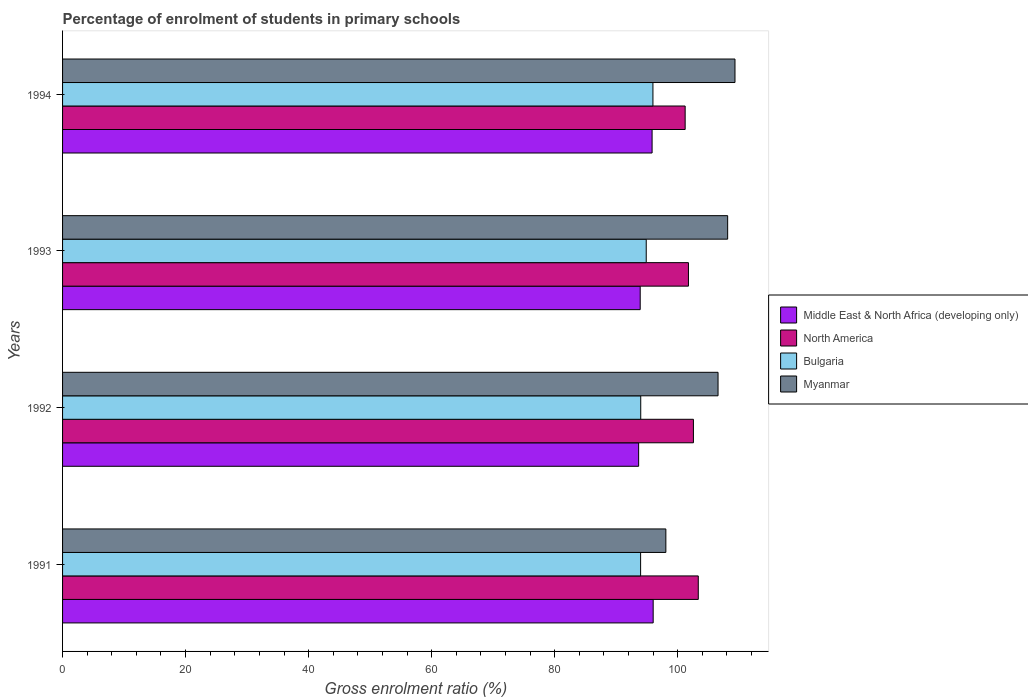How many groups of bars are there?
Your answer should be very brief. 4. Are the number of bars per tick equal to the number of legend labels?
Provide a succinct answer. Yes. How many bars are there on the 3rd tick from the top?
Make the answer very short. 4. How many bars are there on the 1st tick from the bottom?
Your answer should be very brief. 4. What is the label of the 3rd group of bars from the top?
Give a very brief answer. 1992. What is the percentage of students enrolled in primary schools in Bulgaria in 1994?
Offer a very short reply. 95.97. Across all years, what is the maximum percentage of students enrolled in primary schools in North America?
Ensure brevity in your answer.  103.35. Across all years, what is the minimum percentage of students enrolled in primary schools in Myanmar?
Provide a short and direct response. 98.07. What is the total percentage of students enrolled in primary schools in Bulgaria in the graph?
Give a very brief answer. 378.81. What is the difference between the percentage of students enrolled in primary schools in Bulgaria in 1991 and that in 1993?
Your response must be concise. -0.91. What is the difference between the percentage of students enrolled in primary schools in North America in 1993 and the percentage of students enrolled in primary schools in Middle East & North Africa (developing only) in 1991?
Make the answer very short. 5.73. What is the average percentage of students enrolled in primary schools in Bulgaria per year?
Make the answer very short. 94.7. In the year 1992, what is the difference between the percentage of students enrolled in primary schools in North America and percentage of students enrolled in primary schools in Myanmar?
Offer a terse response. -4. In how many years, is the percentage of students enrolled in primary schools in Bulgaria greater than 76 %?
Ensure brevity in your answer.  4. What is the ratio of the percentage of students enrolled in primary schools in Myanmar in 1993 to that in 1994?
Provide a succinct answer. 0.99. What is the difference between the highest and the second highest percentage of students enrolled in primary schools in Myanmar?
Offer a terse response. 1.19. What is the difference between the highest and the lowest percentage of students enrolled in primary schools in Bulgaria?
Provide a short and direct response. 2.01. Is the sum of the percentage of students enrolled in primary schools in North America in 1993 and 1994 greater than the maximum percentage of students enrolled in primary schools in Middle East & North Africa (developing only) across all years?
Provide a succinct answer. Yes. What does the 3rd bar from the bottom in 1994 represents?
Your answer should be compact. Bulgaria. Is it the case that in every year, the sum of the percentage of students enrolled in primary schools in Myanmar and percentage of students enrolled in primary schools in Bulgaria is greater than the percentage of students enrolled in primary schools in Middle East & North Africa (developing only)?
Your answer should be compact. Yes. Are all the bars in the graph horizontal?
Offer a terse response. Yes. How many years are there in the graph?
Offer a terse response. 4. What is the difference between two consecutive major ticks on the X-axis?
Give a very brief answer. 20. Does the graph contain any zero values?
Ensure brevity in your answer.  No. Does the graph contain grids?
Make the answer very short. No. What is the title of the graph?
Keep it short and to the point. Percentage of enrolment of students in primary schools. What is the Gross enrolment ratio (%) in Middle East & North Africa (developing only) in 1991?
Make the answer very short. 96.01. What is the Gross enrolment ratio (%) in North America in 1991?
Provide a succinct answer. 103.35. What is the Gross enrolment ratio (%) of Bulgaria in 1991?
Offer a terse response. 93.97. What is the Gross enrolment ratio (%) of Myanmar in 1991?
Your answer should be very brief. 98.07. What is the Gross enrolment ratio (%) in Middle East & North Africa (developing only) in 1992?
Provide a short and direct response. 93.65. What is the Gross enrolment ratio (%) of North America in 1992?
Offer a very short reply. 102.56. What is the Gross enrolment ratio (%) in Bulgaria in 1992?
Your response must be concise. 93.99. What is the Gross enrolment ratio (%) of Myanmar in 1992?
Your answer should be compact. 106.56. What is the Gross enrolment ratio (%) of Middle East & North Africa (developing only) in 1993?
Give a very brief answer. 93.9. What is the Gross enrolment ratio (%) in North America in 1993?
Make the answer very short. 101.75. What is the Gross enrolment ratio (%) of Bulgaria in 1993?
Provide a short and direct response. 94.88. What is the Gross enrolment ratio (%) in Myanmar in 1993?
Keep it short and to the point. 108.12. What is the Gross enrolment ratio (%) in Middle East & North Africa (developing only) in 1994?
Keep it short and to the point. 95.84. What is the Gross enrolment ratio (%) in North America in 1994?
Offer a very short reply. 101.21. What is the Gross enrolment ratio (%) in Bulgaria in 1994?
Provide a succinct answer. 95.97. What is the Gross enrolment ratio (%) of Myanmar in 1994?
Offer a terse response. 109.31. Across all years, what is the maximum Gross enrolment ratio (%) in Middle East & North Africa (developing only)?
Offer a terse response. 96.01. Across all years, what is the maximum Gross enrolment ratio (%) of North America?
Provide a succinct answer. 103.35. Across all years, what is the maximum Gross enrolment ratio (%) in Bulgaria?
Provide a succinct answer. 95.97. Across all years, what is the maximum Gross enrolment ratio (%) of Myanmar?
Your answer should be compact. 109.31. Across all years, what is the minimum Gross enrolment ratio (%) in Middle East & North Africa (developing only)?
Offer a terse response. 93.65. Across all years, what is the minimum Gross enrolment ratio (%) of North America?
Your answer should be very brief. 101.21. Across all years, what is the minimum Gross enrolment ratio (%) of Bulgaria?
Make the answer very short. 93.97. Across all years, what is the minimum Gross enrolment ratio (%) in Myanmar?
Provide a succinct answer. 98.07. What is the total Gross enrolment ratio (%) in Middle East & North Africa (developing only) in the graph?
Make the answer very short. 379.4. What is the total Gross enrolment ratio (%) in North America in the graph?
Offer a very short reply. 408.86. What is the total Gross enrolment ratio (%) in Bulgaria in the graph?
Give a very brief answer. 378.81. What is the total Gross enrolment ratio (%) of Myanmar in the graph?
Provide a short and direct response. 422.06. What is the difference between the Gross enrolment ratio (%) in Middle East & North Africa (developing only) in 1991 and that in 1992?
Offer a very short reply. 2.36. What is the difference between the Gross enrolment ratio (%) of North America in 1991 and that in 1992?
Offer a terse response. 0.79. What is the difference between the Gross enrolment ratio (%) in Bulgaria in 1991 and that in 1992?
Ensure brevity in your answer.  -0.02. What is the difference between the Gross enrolment ratio (%) of Myanmar in 1991 and that in 1992?
Provide a succinct answer. -8.48. What is the difference between the Gross enrolment ratio (%) of Middle East & North Africa (developing only) in 1991 and that in 1993?
Provide a succinct answer. 2.11. What is the difference between the Gross enrolment ratio (%) in North America in 1991 and that in 1993?
Give a very brief answer. 1.6. What is the difference between the Gross enrolment ratio (%) of Bulgaria in 1991 and that in 1993?
Your answer should be very brief. -0.91. What is the difference between the Gross enrolment ratio (%) of Myanmar in 1991 and that in 1993?
Offer a terse response. -10.05. What is the difference between the Gross enrolment ratio (%) of Middle East & North Africa (developing only) in 1991 and that in 1994?
Give a very brief answer. 0.18. What is the difference between the Gross enrolment ratio (%) in North America in 1991 and that in 1994?
Provide a succinct answer. 2.13. What is the difference between the Gross enrolment ratio (%) of Bulgaria in 1991 and that in 1994?
Keep it short and to the point. -2.01. What is the difference between the Gross enrolment ratio (%) of Myanmar in 1991 and that in 1994?
Your response must be concise. -11.24. What is the difference between the Gross enrolment ratio (%) of Middle East & North Africa (developing only) in 1992 and that in 1993?
Provide a succinct answer. -0.25. What is the difference between the Gross enrolment ratio (%) of North America in 1992 and that in 1993?
Provide a short and direct response. 0.81. What is the difference between the Gross enrolment ratio (%) of Bulgaria in 1992 and that in 1993?
Keep it short and to the point. -0.89. What is the difference between the Gross enrolment ratio (%) of Myanmar in 1992 and that in 1993?
Your answer should be very brief. -1.56. What is the difference between the Gross enrolment ratio (%) of Middle East & North Africa (developing only) in 1992 and that in 1994?
Ensure brevity in your answer.  -2.19. What is the difference between the Gross enrolment ratio (%) in North America in 1992 and that in 1994?
Your response must be concise. 1.34. What is the difference between the Gross enrolment ratio (%) of Bulgaria in 1992 and that in 1994?
Your response must be concise. -1.98. What is the difference between the Gross enrolment ratio (%) in Myanmar in 1992 and that in 1994?
Your response must be concise. -2.75. What is the difference between the Gross enrolment ratio (%) of Middle East & North Africa (developing only) in 1993 and that in 1994?
Ensure brevity in your answer.  -1.93. What is the difference between the Gross enrolment ratio (%) of North America in 1993 and that in 1994?
Provide a short and direct response. 0.54. What is the difference between the Gross enrolment ratio (%) in Bulgaria in 1993 and that in 1994?
Provide a short and direct response. -1.09. What is the difference between the Gross enrolment ratio (%) in Myanmar in 1993 and that in 1994?
Offer a very short reply. -1.19. What is the difference between the Gross enrolment ratio (%) in Middle East & North Africa (developing only) in 1991 and the Gross enrolment ratio (%) in North America in 1992?
Provide a succinct answer. -6.54. What is the difference between the Gross enrolment ratio (%) of Middle East & North Africa (developing only) in 1991 and the Gross enrolment ratio (%) of Bulgaria in 1992?
Offer a terse response. 2.02. What is the difference between the Gross enrolment ratio (%) in Middle East & North Africa (developing only) in 1991 and the Gross enrolment ratio (%) in Myanmar in 1992?
Your answer should be very brief. -10.55. What is the difference between the Gross enrolment ratio (%) of North America in 1991 and the Gross enrolment ratio (%) of Bulgaria in 1992?
Provide a succinct answer. 9.36. What is the difference between the Gross enrolment ratio (%) of North America in 1991 and the Gross enrolment ratio (%) of Myanmar in 1992?
Ensure brevity in your answer.  -3.21. What is the difference between the Gross enrolment ratio (%) in Bulgaria in 1991 and the Gross enrolment ratio (%) in Myanmar in 1992?
Provide a succinct answer. -12.59. What is the difference between the Gross enrolment ratio (%) in Middle East & North Africa (developing only) in 1991 and the Gross enrolment ratio (%) in North America in 1993?
Ensure brevity in your answer.  -5.73. What is the difference between the Gross enrolment ratio (%) in Middle East & North Africa (developing only) in 1991 and the Gross enrolment ratio (%) in Bulgaria in 1993?
Provide a short and direct response. 1.13. What is the difference between the Gross enrolment ratio (%) of Middle East & North Africa (developing only) in 1991 and the Gross enrolment ratio (%) of Myanmar in 1993?
Your response must be concise. -12.11. What is the difference between the Gross enrolment ratio (%) in North America in 1991 and the Gross enrolment ratio (%) in Bulgaria in 1993?
Offer a terse response. 8.46. What is the difference between the Gross enrolment ratio (%) in North America in 1991 and the Gross enrolment ratio (%) in Myanmar in 1993?
Ensure brevity in your answer.  -4.77. What is the difference between the Gross enrolment ratio (%) of Bulgaria in 1991 and the Gross enrolment ratio (%) of Myanmar in 1993?
Make the answer very short. -14.15. What is the difference between the Gross enrolment ratio (%) of Middle East & North Africa (developing only) in 1991 and the Gross enrolment ratio (%) of North America in 1994?
Give a very brief answer. -5.2. What is the difference between the Gross enrolment ratio (%) in Middle East & North Africa (developing only) in 1991 and the Gross enrolment ratio (%) in Bulgaria in 1994?
Make the answer very short. 0.04. What is the difference between the Gross enrolment ratio (%) of Middle East & North Africa (developing only) in 1991 and the Gross enrolment ratio (%) of Myanmar in 1994?
Provide a short and direct response. -13.3. What is the difference between the Gross enrolment ratio (%) of North America in 1991 and the Gross enrolment ratio (%) of Bulgaria in 1994?
Offer a terse response. 7.37. What is the difference between the Gross enrolment ratio (%) of North America in 1991 and the Gross enrolment ratio (%) of Myanmar in 1994?
Offer a terse response. -5.97. What is the difference between the Gross enrolment ratio (%) in Bulgaria in 1991 and the Gross enrolment ratio (%) in Myanmar in 1994?
Keep it short and to the point. -15.34. What is the difference between the Gross enrolment ratio (%) of Middle East & North Africa (developing only) in 1992 and the Gross enrolment ratio (%) of North America in 1993?
Ensure brevity in your answer.  -8.1. What is the difference between the Gross enrolment ratio (%) of Middle East & North Africa (developing only) in 1992 and the Gross enrolment ratio (%) of Bulgaria in 1993?
Offer a very short reply. -1.23. What is the difference between the Gross enrolment ratio (%) in Middle East & North Africa (developing only) in 1992 and the Gross enrolment ratio (%) in Myanmar in 1993?
Your response must be concise. -14.47. What is the difference between the Gross enrolment ratio (%) of North America in 1992 and the Gross enrolment ratio (%) of Bulgaria in 1993?
Offer a very short reply. 7.67. What is the difference between the Gross enrolment ratio (%) in North America in 1992 and the Gross enrolment ratio (%) in Myanmar in 1993?
Provide a succinct answer. -5.56. What is the difference between the Gross enrolment ratio (%) of Bulgaria in 1992 and the Gross enrolment ratio (%) of Myanmar in 1993?
Give a very brief answer. -14.13. What is the difference between the Gross enrolment ratio (%) of Middle East & North Africa (developing only) in 1992 and the Gross enrolment ratio (%) of North America in 1994?
Offer a very short reply. -7.56. What is the difference between the Gross enrolment ratio (%) in Middle East & North Africa (developing only) in 1992 and the Gross enrolment ratio (%) in Bulgaria in 1994?
Offer a terse response. -2.32. What is the difference between the Gross enrolment ratio (%) of Middle East & North Africa (developing only) in 1992 and the Gross enrolment ratio (%) of Myanmar in 1994?
Offer a terse response. -15.66. What is the difference between the Gross enrolment ratio (%) of North America in 1992 and the Gross enrolment ratio (%) of Bulgaria in 1994?
Provide a short and direct response. 6.58. What is the difference between the Gross enrolment ratio (%) in North America in 1992 and the Gross enrolment ratio (%) in Myanmar in 1994?
Keep it short and to the point. -6.75. What is the difference between the Gross enrolment ratio (%) in Bulgaria in 1992 and the Gross enrolment ratio (%) in Myanmar in 1994?
Give a very brief answer. -15.32. What is the difference between the Gross enrolment ratio (%) of Middle East & North Africa (developing only) in 1993 and the Gross enrolment ratio (%) of North America in 1994?
Your response must be concise. -7.31. What is the difference between the Gross enrolment ratio (%) of Middle East & North Africa (developing only) in 1993 and the Gross enrolment ratio (%) of Bulgaria in 1994?
Offer a very short reply. -2.07. What is the difference between the Gross enrolment ratio (%) of Middle East & North Africa (developing only) in 1993 and the Gross enrolment ratio (%) of Myanmar in 1994?
Provide a succinct answer. -15.41. What is the difference between the Gross enrolment ratio (%) of North America in 1993 and the Gross enrolment ratio (%) of Bulgaria in 1994?
Provide a short and direct response. 5.77. What is the difference between the Gross enrolment ratio (%) in North America in 1993 and the Gross enrolment ratio (%) in Myanmar in 1994?
Provide a succinct answer. -7.56. What is the difference between the Gross enrolment ratio (%) of Bulgaria in 1993 and the Gross enrolment ratio (%) of Myanmar in 1994?
Your response must be concise. -14.43. What is the average Gross enrolment ratio (%) of Middle East & North Africa (developing only) per year?
Your answer should be compact. 94.85. What is the average Gross enrolment ratio (%) in North America per year?
Your answer should be very brief. 102.21. What is the average Gross enrolment ratio (%) in Bulgaria per year?
Provide a succinct answer. 94.7. What is the average Gross enrolment ratio (%) in Myanmar per year?
Your answer should be very brief. 105.52. In the year 1991, what is the difference between the Gross enrolment ratio (%) in Middle East & North Africa (developing only) and Gross enrolment ratio (%) in North America?
Your answer should be compact. -7.33. In the year 1991, what is the difference between the Gross enrolment ratio (%) in Middle East & North Africa (developing only) and Gross enrolment ratio (%) in Bulgaria?
Your response must be concise. 2.04. In the year 1991, what is the difference between the Gross enrolment ratio (%) of Middle East & North Africa (developing only) and Gross enrolment ratio (%) of Myanmar?
Make the answer very short. -2.06. In the year 1991, what is the difference between the Gross enrolment ratio (%) of North America and Gross enrolment ratio (%) of Bulgaria?
Offer a very short reply. 9.38. In the year 1991, what is the difference between the Gross enrolment ratio (%) in North America and Gross enrolment ratio (%) in Myanmar?
Keep it short and to the point. 5.27. In the year 1991, what is the difference between the Gross enrolment ratio (%) in Bulgaria and Gross enrolment ratio (%) in Myanmar?
Provide a succinct answer. -4.11. In the year 1992, what is the difference between the Gross enrolment ratio (%) of Middle East & North Africa (developing only) and Gross enrolment ratio (%) of North America?
Your answer should be very brief. -8.91. In the year 1992, what is the difference between the Gross enrolment ratio (%) in Middle East & North Africa (developing only) and Gross enrolment ratio (%) in Bulgaria?
Your answer should be compact. -0.34. In the year 1992, what is the difference between the Gross enrolment ratio (%) of Middle East & North Africa (developing only) and Gross enrolment ratio (%) of Myanmar?
Make the answer very short. -12.91. In the year 1992, what is the difference between the Gross enrolment ratio (%) of North America and Gross enrolment ratio (%) of Bulgaria?
Your answer should be compact. 8.57. In the year 1992, what is the difference between the Gross enrolment ratio (%) of North America and Gross enrolment ratio (%) of Myanmar?
Provide a succinct answer. -4. In the year 1992, what is the difference between the Gross enrolment ratio (%) of Bulgaria and Gross enrolment ratio (%) of Myanmar?
Your answer should be very brief. -12.57. In the year 1993, what is the difference between the Gross enrolment ratio (%) in Middle East & North Africa (developing only) and Gross enrolment ratio (%) in North America?
Your answer should be very brief. -7.84. In the year 1993, what is the difference between the Gross enrolment ratio (%) of Middle East & North Africa (developing only) and Gross enrolment ratio (%) of Bulgaria?
Ensure brevity in your answer.  -0.98. In the year 1993, what is the difference between the Gross enrolment ratio (%) of Middle East & North Africa (developing only) and Gross enrolment ratio (%) of Myanmar?
Your answer should be compact. -14.22. In the year 1993, what is the difference between the Gross enrolment ratio (%) in North America and Gross enrolment ratio (%) in Bulgaria?
Your response must be concise. 6.86. In the year 1993, what is the difference between the Gross enrolment ratio (%) of North America and Gross enrolment ratio (%) of Myanmar?
Keep it short and to the point. -6.37. In the year 1993, what is the difference between the Gross enrolment ratio (%) of Bulgaria and Gross enrolment ratio (%) of Myanmar?
Provide a short and direct response. -13.24. In the year 1994, what is the difference between the Gross enrolment ratio (%) of Middle East & North Africa (developing only) and Gross enrolment ratio (%) of North America?
Your answer should be compact. -5.38. In the year 1994, what is the difference between the Gross enrolment ratio (%) of Middle East & North Africa (developing only) and Gross enrolment ratio (%) of Bulgaria?
Offer a terse response. -0.14. In the year 1994, what is the difference between the Gross enrolment ratio (%) in Middle East & North Africa (developing only) and Gross enrolment ratio (%) in Myanmar?
Your answer should be very brief. -13.47. In the year 1994, what is the difference between the Gross enrolment ratio (%) of North America and Gross enrolment ratio (%) of Bulgaria?
Make the answer very short. 5.24. In the year 1994, what is the difference between the Gross enrolment ratio (%) in North America and Gross enrolment ratio (%) in Myanmar?
Your response must be concise. -8.1. In the year 1994, what is the difference between the Gross enrolment ratio (%) in Bulgaria and Gross enrolment ratio (%) in Myanmar?
Offer a very short reply. -13.34. What is the ratio of the Gross enrolment ratio (%) of Middle East & North Africa (developing only) in 1991 to that in 1992?
Keep it short and to the point. 1.03. What is the ratio of the Gross enrolment ratio (%) in North America in 1991 to that in 1992?
Keep it short and to the point. 1.01. What is the ratio of the Gross enrolment ratio (%) of Myanmar in 1991 to that in 1992?
Give a very brief answer. 0.92. What is the ratio of the Gross enrolment ratio (%) in Middle East & North Africa (developing only) in 1991 to that in 1993?
Your response must be concise. 1.02. What is the ratio of the Gross enrolment ratio (%) in North America in 1991 to that in 1993?
Offer a terse response. 1.02. What is the ratio of the Gross enrolment ratio (%) in Bulgaria in 1991 to that in 1993?
Make the answer very short. 0.99. What is the ratio of the Gross enrolment ratio (%) in Myanmar in 1991 to that in 1993?
Offer a very short reply. 0.91. What is the ratio of the Gross enrolment ratio (%) of North America in 1991 to that in 1994?
Your answer should be compact. 1.02. What is the ratio of the Gross enrolment ratio (%) of Bulgaria in 1991 to that in 1994?
Your answer should be very brief. 0.98. What is the ratio of the Gross enrolment ratio (%) of Myanmar in 1991 to that in 1994?
Your answer should be compact. 0.9. What is the ratio of the Gross enrolment ratio (%) in Bulgaria in 1992 to that in 1993?
Make the answer very short. 0.99. What is the ratio of the Gross enrolment ratio (%) in Myanmar in 1992 to that in 1993?
Keep it short and to the point. 0.99. What is the ratio of the Gross enrolment ratio (%) in Middle East & North Africa (developing only) in 1992 to that in 1994?
Your answer should be compact. 0.98. What is the ratio of the Gross enrolment ratio (%) in North America in 1992 to that in 1994?
Give a very brief answer. 1.01. What is the ratio of the Gross enrolment ratio (%) of Bulgaria in 1992 to that in 1994?
Your response must be concise. 0.98. What is the ratio of the Gross enrolment ratio (%) of Myanmar in 1992 to that in 1994?
Ensure brevity in your answer.  0.97. What is the ratio of the Gross enrolment ratio (%) of Middle East & North Africa (developing only) in 1993 to that in 1994?
Give a very brief answer. 0.98. What is the ratio of the Gross enrolment ratio (%) of North America in 1993 to that in 1994?
Your answer should be very brief. 1.01. What is the ratio of the Gross enrolment ratio (%) of Bulgaria in 1993 to that in 1994?
Make the answer very short. 0.99. What is the difference between the highest and the second highest Gross enrolment ratio (%) in Middle East & North Africa (developing only)?
Keep it short and to the point. 0.18. What is the difference between the highest and the second highest Gross enrolment ratio (%) in North America?
Offer a very short reply. 0.79. What is the difference between the highest and the second highest Gross enrolment ratio (%) of Bulgaria?
Your answer should be very brief. 1.09. What is the difference between the highest and the second highest Gross enrolment ratio (%) in Myanmar?
Your answer should be compact. 1.19. What is the difference between the highest and the lowest Gross enrolment ratio (%) of Middle East & North Africa (developing only)?
Keep it short and to the point. 2.36. What is the difference between the highest and the lowest Gross enrolment ratio (%) in North America?
Offer a very short reply. 2.13. What is the difference between the highest and the lowest Gross enrolment ratio (%) of Bulgaria?
Provide a succinct answer. 2.01. What is the difference between the highest and the lowest Gross enrolment ratio (%) in Myanmar?
Provide a short and direct response. 11.24. 